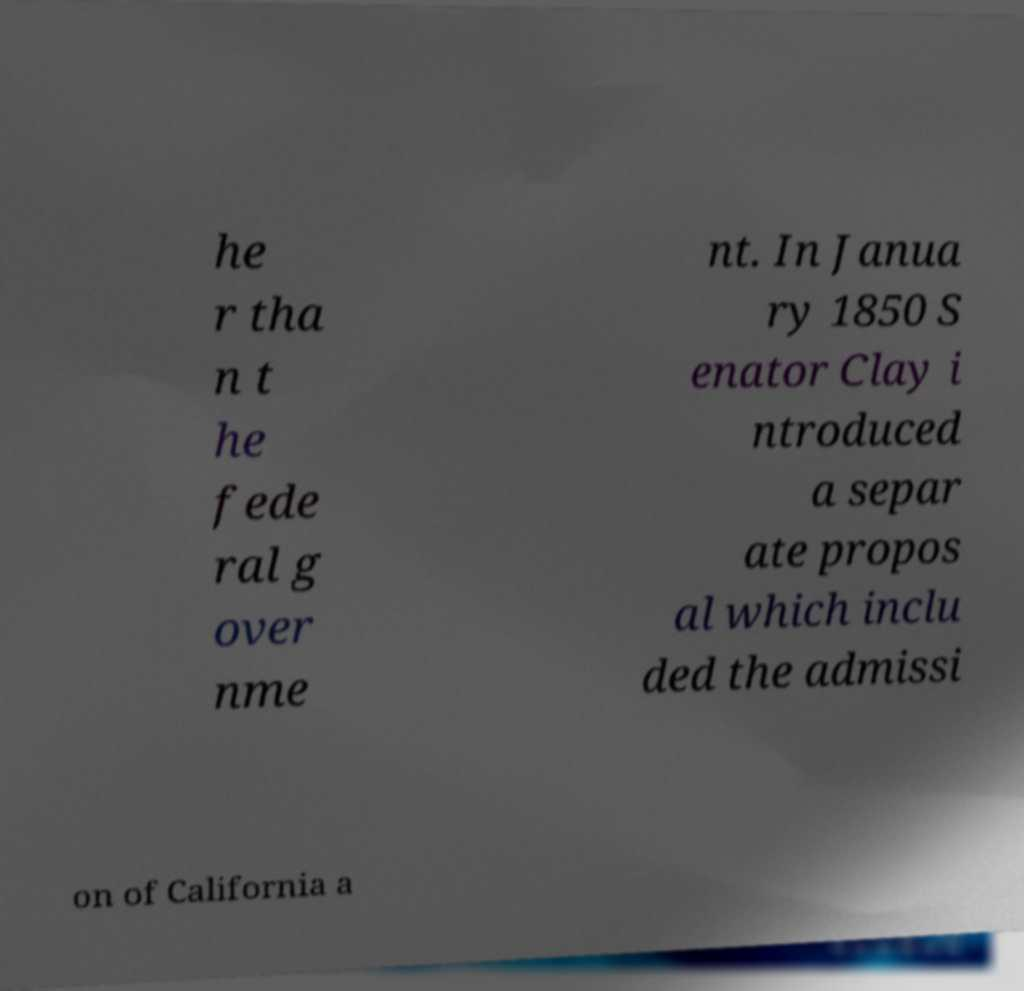What messages or text are displayed in this image? I need them in a readable, typed format. he r tha n t he fede ral g over nme nt. In Janua ry 1850 S enator Clay i ntroduced a separ ate propos al which inclu ded the admissi on of California a 